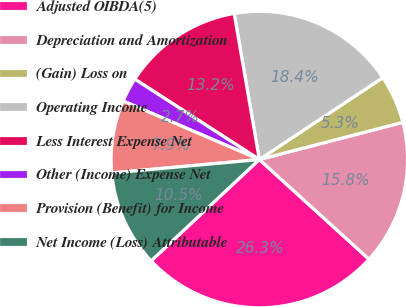Convert chart. <chart><loc_0><loc_0><loc_500><loc_500><pie_chart><fcel>Adjusted OIBDA(5)<fcel>Depreciation and Amortization<fcel>(Gain) Loss on<fcel>Operating Income<fcel>Less Interest Expense Net<fcel>Other (Income) Expense Net<fcel>Provision (Benefit) for Income<fcel>Net Income (Loss) Attributable<nl><fcel>26.28%<fcel>15.78%<fcel>5.28%<fcel>18.4%<fcel>13.16%<fcel>2.66%<fcel>7.91%<fcel>10.53%<nl></chart> 